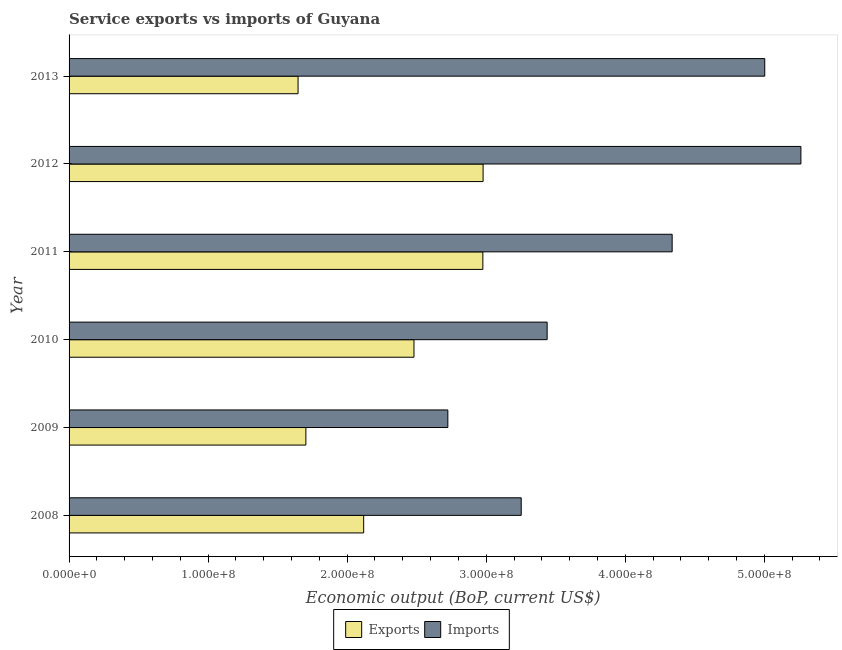How many bars are there on the 2nd tick from the top?
Offer a very short reply. 2. What is the amount of service imports in 2012?
Ensure brevity in your answer.  5.26e+08. Across all years, what is the maximum amount of service exports?
Your response must be concise. 2.98e+08. Across all years, what is the minimum amount of service imports?
Your answer should be very brief. 2.72e+08. In which year was the amount of service imports maximum?
Provide a succinct answer. 2012. In which year was the amount of service imports minimum?
Your response must be concise. 2009. What is the total amount of service exports in the graph?
Your answer should be very brief. 1.39e+09. What is the difference between the amount of service imports in 2008 and that in 2010?
Your response must be concise. -1.86e+07. What is the difference between the amount of service imports in 2012 and the amount of service exports in 2010?
Provide a short and direct response. 2.78e+08. What is the average amount of service imports per year?
Keep it short and to the point. 4.00e+08. In the year 2008, what is the difference between the amount of service exports and amount of service imports?
Your answer should be very brief. -1.13e+08. Is the amount of service imports in 2010 less than that in 2012?
Your answer should be compact. Yes. What is the difference between the highest and the second highest amount of service exports?
Provide a short and direct response. 1.72e+05. What is the difference between the highest and the lowest amount of service imports?
Offer a very short reply. 2.54e+08. In how many years, is the amount of service exports greater than the average amount of service exports taken over all years?
Your answer should be very brief. 3. Is the sum of the amount of service exports in 2009 and 2012 greater than the maximum amount of service imports across all years?
Keep it short and to the point. No. What does the 2nd bar from the top in 2008 represents?
Give a very brief answer. Exports. What does the 2nd bar from the bottom in 2010 represents?
Ensure brevity in your answer.  Imports. How many bars are there?
Ensure brevity in your answer.  12. How many legend labels are there?
Make the answer very short. 2. What is the title of the graph?
Your answer should be compact. Service exports vs imports of Guyana. What is the label or title of the X-axis?
Provide a short and direct response. Economic output (BoP, current US$). What is the Economic output (BoP, current US$) of Exports in 2008?
Offer a terse response. 2.12e+08. What is the Economic output (BoP, current US$) of Imports in 2008?
Keep it short and to the point. 3.25e+08. What is the Economic output (BoP, current US$) of Exports in 2009?
Keep it short and to the point. 1.70e+08. What is the Economic output (BoP, current US$) in Imports in 2009?
Give a very brief answer. 2.72e+08. What is the Economic output (BoP, current US$) of Exports in 2010?
Offer a terse response. 2.48e+08. What is the Economic output (BoP, current US$) of Imports in 2010?
Your answer should be very brief. 3.44e+08. What is the Economic output (BoP, current US$) in Exports in 2011?
Provide a short and direct response. 2.98e+08. What is the Economic output (BoP, current US$) in Imports in 2011?
Ensure brevity in your answer.  4.34e+08. What is the Economic output (BoP, current US$) in Exports in 2012?
Your answer should be very brief. 2.98e+08. What is the Economic output (BoP, current US$) of Imports in 2012?
Make the answer very short. 5.26e+08. What is the Economic output (BoP, current US$) in Exports in 2013?
Offer a very short reply. 1.65e+08. What is the Economic output (BoP, current US$) of Imports in 2013?
Offer a very short reply. 5.00e+08. Across all years, what is the maximum Economic output (BoP, current US$) in Exports?
Your answer should be very brief. 2.98e+08. Across all years, what is the maximum Economic output (BoP, current US$) of Imports?
Provide a short and direct response. 5.26e+08. Across all years, what is the minimum Economic output (BoP, current US$) of Exports?
Make the answer very short. 1.65e+08. Across all years, what is the minimum Economic output (BoP, current US$) in Imports?
Ensure brevity in your answer.  2.72e+08. What is the total Economic output (BoP, current US$) in Exports in the graph?
Provide a succinct answer. 1.39e+09. What is the total Economic output (BoP, current US$) of Imports in the graph?
Offer a terse response. 2.40e+09. What is the difference between the Economic output (BoP, current US$) in Exports in 2008 and that in 2009?
Make the answer very short. 4.16e+07. What is the difference between the Economic output (BoP, current US$) in Imports in 2008 and that in 2009?
Offer a terse response. 5.28e+07. What is the difference between the Economic output (BoP, current US$) of Exports in 2008 and that in 2010?
Make the answer very short. -3.62e+07. What is the difference between the Economic output (BoP, current US$) in Imports in 2008 and that in 2010?
Your answer should be compact. -1.86e+07. What is the difference between the Economic output (BoP, current US$) in Exports in 2008 and that in 2011?
Offer a terse response. -8.57e+07. What is the difference between the Economic output (BoP, current US$) in Imports in 2008 and that in 2011?
Keep it short and to the point. -1.09e+08. What is the difference between the Economic output (BoP, current US$) in Exports in 2008 and that in 2012?
Your answer should be compact. -8.59e+07. What is the difference between the Economic output (BoP, current US$) of Imports in 2008 and that in 2012?
Provide a short and direct response. -2.01e+08. What is the difference between the Economic output (BoP, current US$) of Exports in 2008 and that in 2013?
Ensure brevity in your answer.  4.72e+07. What is the difference between the Economic output (BoP, current US$) in Imports in 2008 and that in 2013?
Make the answer very short. -1.75e+08. What is the difference between the Economic output (BoP, current US$) of Exports in 2009 and that in 2010?
Offer a terse response. -7.77e+07. What is the difference between the Economic output (BoP, current US$) of Imports in 2009 and that in 2010?
Your response must be concise. -7.14e+07. What is the difference between the Economic output (BoP, current US$) of Exports in 2009 and that in 2011?
Your response must be concise. -1.27e+08. What is the difference between the Economic output (BoP, current US$) of Imports in 2009 and that in 2011?
Offer a terse response. -1.61e+08. What is the difference between the Economic output (BoP, current US$) in Exports in 2009 and that in 2012?
Make the answer very short. -1.27e+08. What is the difference between the Economic output (BoP, current US$) of Imports in 2009 and that in 2012?
Your response must be concise. -2.54e+08. What is the difference between the Economic output (BoP, current US$) in Exports in 2009 and that in 2013?
Make the answer very short. 5.62e+06. What is the difference between the Economic output (BoP, current US$) in Imports in 2009 and that in 2013?
Keep it short and to the point. -2.28e+08. What is the difference between the Economic output (BoP, current US$) of Exports in 2010 and that in 2011?
Provide a succinct answer. -4.95e+07. What is the difference between the Economic output (BoP, current US$) of Imports in 2010 and that in 2011?
Make the answer very short. -8.99e+07. What is the difference between the Economic output (BoP, current US$) in Exports in 2010 and that in 2012?
Make the answer very short. -4.97e+07. What is the difference between the Economic output (BoP, current US$) in Imports in 2010 and that in 2012?
Your answer should be very brief. -1.83e+08. What is the difference between the Economic output (BoP, current US$) in Exports in 2010 and that in 2013?
Ensure brevity in your answer.  8.34e+07. What is the difference between the Economic output (BoP, current US$) of Imports in 2010 and that in 2013?
Your answer should be compact. -1.57e+08. What is the difference between the Economic output (BoP, current US$) of Exports in 2011 and that in 2012?
Make the answer very short. -1.72e+05. What is the difference between the Economic output (BoP, current US$) in Imports in 2011 and that in 2012?
Keep it short and to the point. -9.26e+07. What is the difference between the Economic output (BoP, current US$) in Exports in 2011 and that in 2013?
Offer a very short reply. 1.33e+08. What is the difference between the Economic output (BoP, current US$) of Imports in 2011 and that in 2013?
Provide a succinct answer. -6.66e+07. What is the difference between the Economic output (BoP, current US$) in Exports in 2012 and that in 2013?
Your answer should be very brief. 1.33e+08. What is the difference between the Economic output (BoP, current US$) of Imports in 2012 and that in 2013?
Provide a short and direct response. 2.60e+07. What is the difference between the Economic output (BoP, current US$) of Exports in 2008 and the Economic output (BoP, current US$) of Imports in 2009?
Offer a terse response. -6.05e+07. What is the difference between the Economic output (BoP, current US$) in Exports in 2008 and the Economic output (BoP, current US$) in Imports in 2010?
Offer a terse response. -1.32e+08. What is the difference between the Economic output (BoP, current US$) of Exports in 2008 and the Economic output (BoP, current US$) of Imports in 2011?
Your answer should be very brief. -2.22e+08. What is the difference between the Economic output (BoP, current US$) in Exports in 2008 and the Economic output (BoP, current US$) in Imports in 2012?
Provide a succinct answer. -3.14e+08. What is the difference between the Economic output (BoP, current US$) of Exports in 2008 and the Economic output (BoP, current US$) of Imports in 2013?
Keep it short and to the point. -2.88e+08. What is the difference between the Economic output (BoP, current US$) of Exports in 2009 and the Economic output (BoP, current US$) of Imports in 2010?
Offer a terse response. -1.74e+08. What is the difference between the Economic output (BoP, current US$) in Exports in 2009 and the Economic output (BoP, current US$) in Imports in 2011?
Your answer should be compact. -2.63e+08. What is the difference between the Economic output (BoP, current US$) of Exports in 2009 and the Economic output (BoP, current US$) of Imports in 2012?
Keep it short and to the point. -3.56e+08. What is the difference between the Economic output (BoP, current US$) in Exports in 2009 and the Economic output (BoP, current US$) in Imports in 2013?
Give a very brief answer. -3.30e+08. What is the difference between the Economic output (BoP, current US$) in Exports in 2010 and the Economic output (BoP, current US$) in Imports in 2011?
Your answer should be compact. -1.86e+08. What is the difference between the Economic output (BoP, current US$) in Exports in 2010 and the Economic output (BoP, current US$) in Imports in 2012?
Provide a short and direct response. -2.78e+08. What is the difference between the Economic output (BoP, current US$) of Exports in 2010 and the Economic output (BoP, current US$) of Imports in 2013?
Offer a very short reply. -2.52e+08. What is the difference between the Economic output (BoP, current US$) of Exports in 2011 and the Economic output (BoP, current US$) of Imports in 2012?
Provide a short and direct response. -2.29e+08. What is the difference between the Economic output (BoP, current US$) of Exports in 2011 and the Economic output (BoP, current US$) of Imports in 2013?
Your response must be concise. -2.03e+08. What is the difference between the Economic output (BoP, current US$) of Exports in 2012 and the Economic output (BoP, current US$) of Imports in 2013?
Your answer should be compact. -2.03e+08. What is the average Economic output (BoP, current US$) of Exports per year?
Your answer should be compact. 2.32e+08. What is the average Economic output (BoP, current US$) in Imports per year?
Your response must be concise. 4.00e+08. In the year 2008, what is the difference between the Economic output (BoP, current US$) of Exports and Economic output (BoP, current US$) of Imports?
Offer a terse response. -1.13e+08. In the year 2009, what is the difference between the Economic output (BoP, current US$) in Exports and Economic output (BoP, current US$) in Imports?
Provide a short and direct response. -1.02e+08. In the year 2010, what is the difference between the Economic output (BoP, current US$) of Exports and Economic output (BoP, current US$) of Imports?
Your answer should be compact. -9.58e+07. In the year 2011, what is the difference between the Economic output (BoP, current US$) in Exports and Economic output (BoP, current US$) in Imports?
Offer a very short reply. -1.36e+08. In the year 2012, what is the difference between the Economic output (BoP, current US$) of Exports and Economic output (BoP, current US$) of Imports?
Offer a very short reply. -2.29e+08. In the year 2013, what is the difference between the Economic output (BoP, current US$) in Exports and Economic output (BoP, current US$) in Imports?
Give a very brief answer. -3.36e+08. What is the ratio of the Economic output (BoP, current US$) in Exports in 2008 to that in 2009?
Provide a short and direct response. 1.24. What is the ratio of the Economic output (BoP, current US$) in Imports in 2008 to that in 2009?
Provide a succinct answer. 1.19. What is the ratio of the Economic output (BoP, current US$) of Exports in 2008 to that in 2010?
Your response must be concise. 0.85. What is the ratio of the Economic output (BoP, current US$) in Imports in 2008 to that in 2010?
Your answer should be very brief. 0.95. What is the ratio of the Economic output (BoP, current US$) of Exports in 2008 to that in 2011?
Keep it short and to the point. 0.71. What is the ratio of the Economic output (BoP, current US$) in Imports in 2008 to that in 2011?
Keep it short and to the point. 0.75. What is the ratio of the Economic output (BoP, current US$) in Exports in 2008 to that in 2012?
Keep it short and to the point. 0.71. What is the ratio of the Economic output (BoP, current US$) in Imports in 2008 to that in 2012?
Your answer should be very brief. 0.62. What is the ratio of the Economic output (BoP, current US$) of Exports in 2008 to that in 2013?
Provide a succinct answer. 1.29. What is the ratio of the Economic output (BoP, current US$) in Imports in 2008 to that in 2013?
Provide a succinct answer. 0.65. What is the ratio of the Economic output (BoP, current US$) in Exports in 2009 to that in 2010?
Offer a terse response. 0.69. What is the ratio of the Economic output (BoP, current US$) of Imports in 2009 to that in 2010?
Give a very brief answer. 0.79. What is the ratio of the Economic output (BoP, current US$) of Exports in 2009 to that in 2011?
Make the answer very short. 0.57. What is the ratio of the Economic output (BoP, current US$) in Imports in 2009 to that in 2011?
Give a very brief answer. 0.63. What is the ratio of the Economic output (BoP, current US$) of Exports in 2009 to that in 2012?
Provide a short and direct response. 0.57. What is the ratio of the Economic output (BoP, current US$) of Imports in 2009 to that in 2012?
Your response must be concise. 0.52. What is the ratio of the Economic output (BoP, current US$) in Exports in 2009 to that in 2013?
Provide a short and direct response. 1.03. What is the ratio of the Economic output (BoP, current US$) of Imports in 2009 to that in 2013?
Your response must be concise. 0.54. What is the ratio of the Economic output (BoP, current US$) in Exports in 2010 to that in 2011?
Give a very brief answer. 0.83. What is the ratio of the Economic output (BoP, current US$) in Imports in 2010 to that in 2011?
Offer a terse response. 0.79. What is the ratio of the Economic output (BoP, current US$) of Exports in 2010 to that in 2012?
Offer a very short reply. 0.83. What is the ratio of the Economic output (BoP, current US$) of Imports in 2010 to that in 2012?
Offer a very short reply. 0.65. What is the ratio of the Economic output (BoP, current US$) of Exports in 2010 to that in 2013?
Keep it short and to the point. 1.51. What is the ratio of the Economic output (BoP, current US$) of Imports in 2010 to that in 2013?
Ensure brevity in your answer.  0.69. What is the ratio of the Economic output (BoP, current US$) of Exports in 2011 to that in 2012?
Offer a very short reply. 1. What is the ratio of the Economic output (BoP, current US$) of Imports in 2011 to that in 2012?
Keep it short and to the point. 0.82. What is the ratio of the Economic output (BoP, current US$) of Exports in 2011 to that in 2013?
Offer a very short reply. 1.81. What is the ratio of the Economic output (BoP, current US$) in Imports in 2011 to that in 2013?
Make the answer very short. 0.87. What is the ratio of the Economic output (BoP, current US$) in Exports in 2012 to that in 2013?
Offer a very short reply. 1.81. What is the ratio of the Economic output (BoP, current US$) in Imports in 2012 to that in 2013?
Ensure brevity in your answer.  1.05. What is the difference between the highest and the second highest Economic output (BoP, current US$) of Exports?
Offer a very short reply. 1.72e+05. What is the difference between the highest and the second highest Economic output (BoP, current US$) in Imports?
Your response must be concise. 2.60e+07. What is the difference between the highest and the lowest Economic output (BoP, current US$) in Exports?
Make the answer very short. 1.33e+08. What is the difference between the highest and the lowest Economic output (BoP, current US$) of Imports?
Your answer should be very brief. 2.54e+08. 